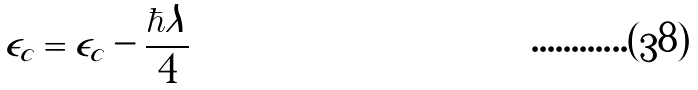Convert formula to latex. <formula><loc_0><loc_0><loc_500><loc_500>\tilde { \epsilon } _ { c } = \epsilon _ { c } - \frac { \hbar { \lambda } } { 4 }</formula> 